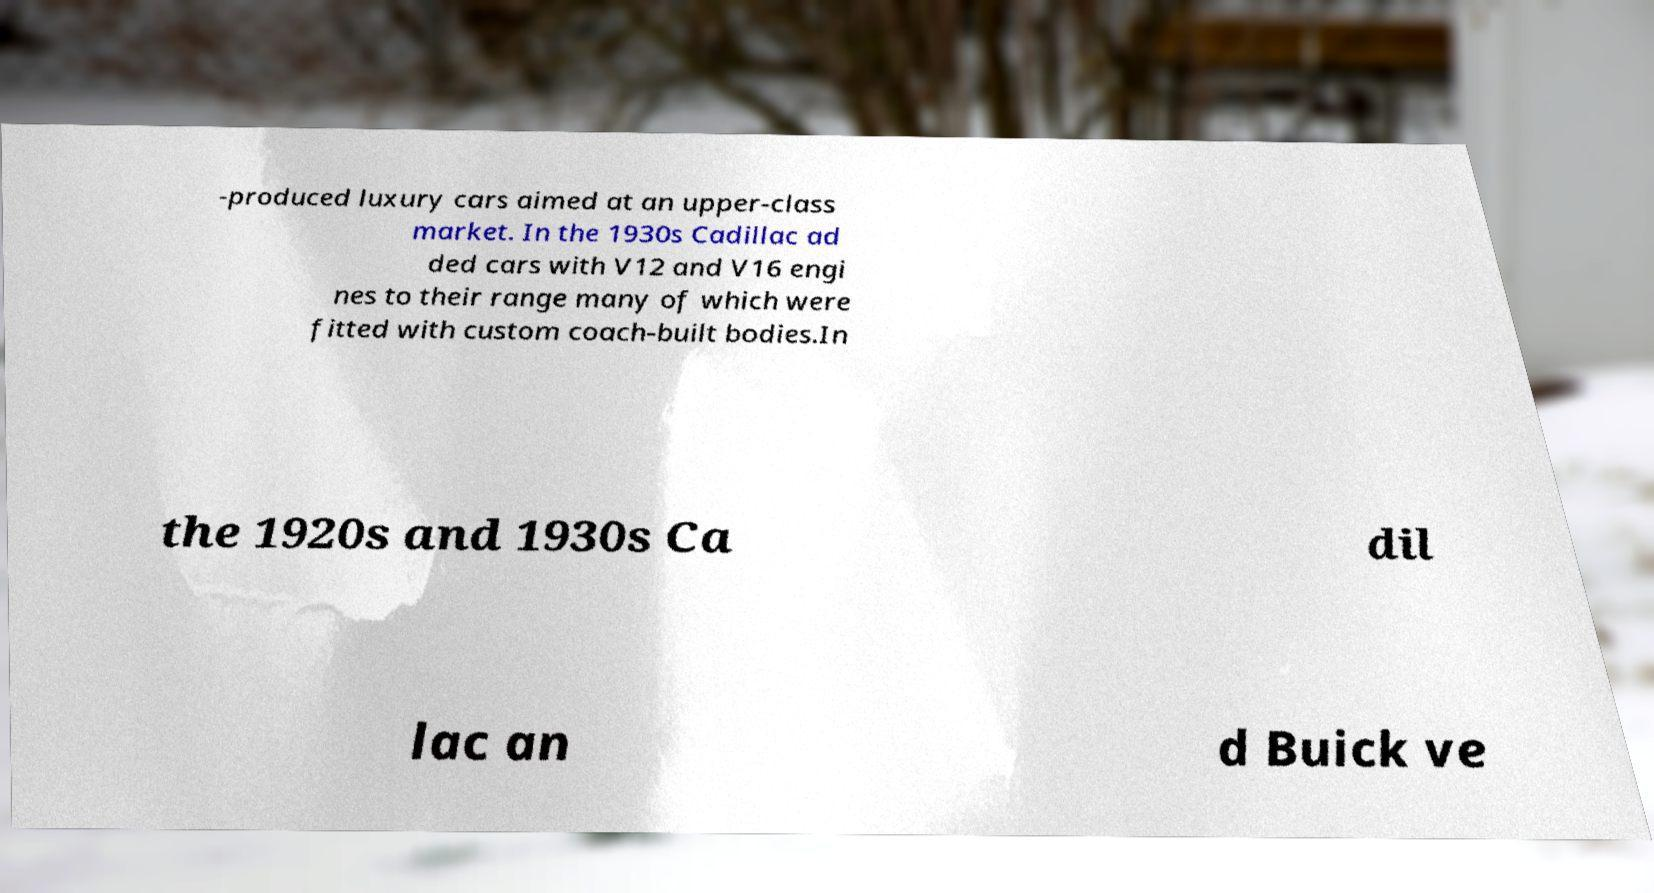Can you accurately transcribe the text from the provided image for me? -produced luxury cars aimed at an upper-class market. In the 1930s Cadillac ad ded cars with V12 and V16 engi nes to their range many of which were fitted with custom coach-built bodies.In the 1920s and 1930s Ca dil lac an d Buick ve 